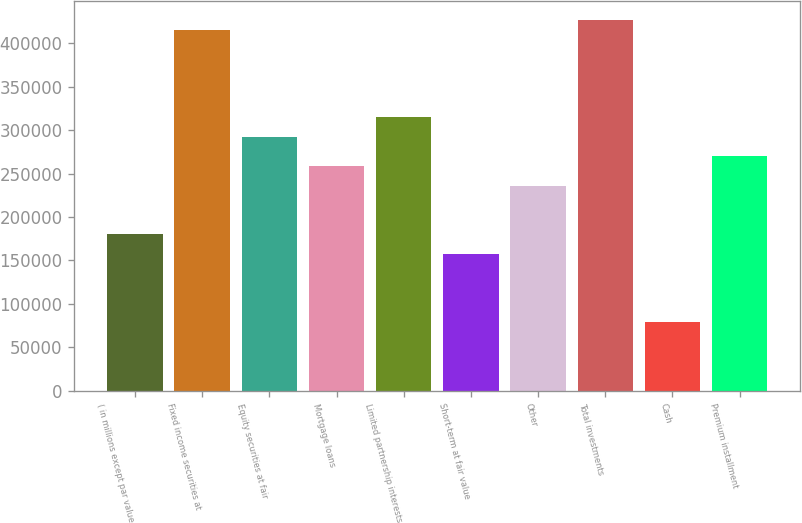Convert chart to OTSL. <chart><loc_0><loc_0><loc_500><loc_500><bar_chart><fcel>( in millions except par value<fcel>Fixed income securities at<fcel>Equity securities at fair<fcel>Mortgage loans<fcel>Limited partnership interests<fcel>Short-term at fair value<fcel>Other<fcel>Total investments<fcel>Cash<fcel>Premium installment<nl><fcel>179873<fcel>415953<fcel>292292<fcel>258567<fcel>314776<fcel>157390<fcel>236083<fcel>427195<fcel>78696.3<fcel>269809<nl></chart> 